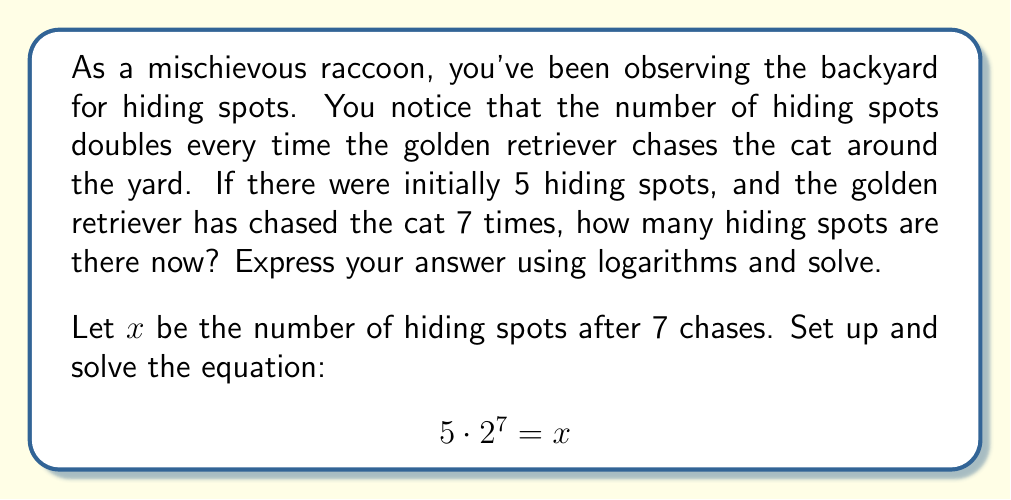Give your solution to this math problem. Let's solve this problem step by step using properties of logarithms:

1) We start with the equation: $5 \cdot 2^7 = x$

2) To solve for $x$, we can take the logarithm (base 2) of both sides:
   $$\log_2(5 \cdot 2^7) = \log_2(x)$$

3) Using the logarithm property $\log_a(M \cdot N) = \log_a(M) + \log_a(N)$, we get:
   $$\log_2(5) + \log_2(2^7) = \log_2(x)$$

4) Using the logarithm property $\log_a(a^n) = n$, we simplify:
   $$\log_2(5) + 7 = \log_2(x)$$

5) Now, we can solve for $x$ by raising 2 to the power of both sides:
   $$2^{\log_2(5) + 7} = 2^{\log_2(x)} = x$$

6) Using the exponential property $a^{b+c} = a^b \cdot a^c$, we get:
   $$2^{\log_2(5)} \cdot 2^7 = x$$

7) Simplify $2^{\log_2(5)} = 5$, so:
   $$5 \cdot 2^7 = x$$

8) Calculate $2^7 = 128$:
   $$5 \cdot 128 = x = 640$$

Therefore, after 7 chases, there are 640 hiding spots in the backyard.
Answer: $x = 640$ hiding spots 